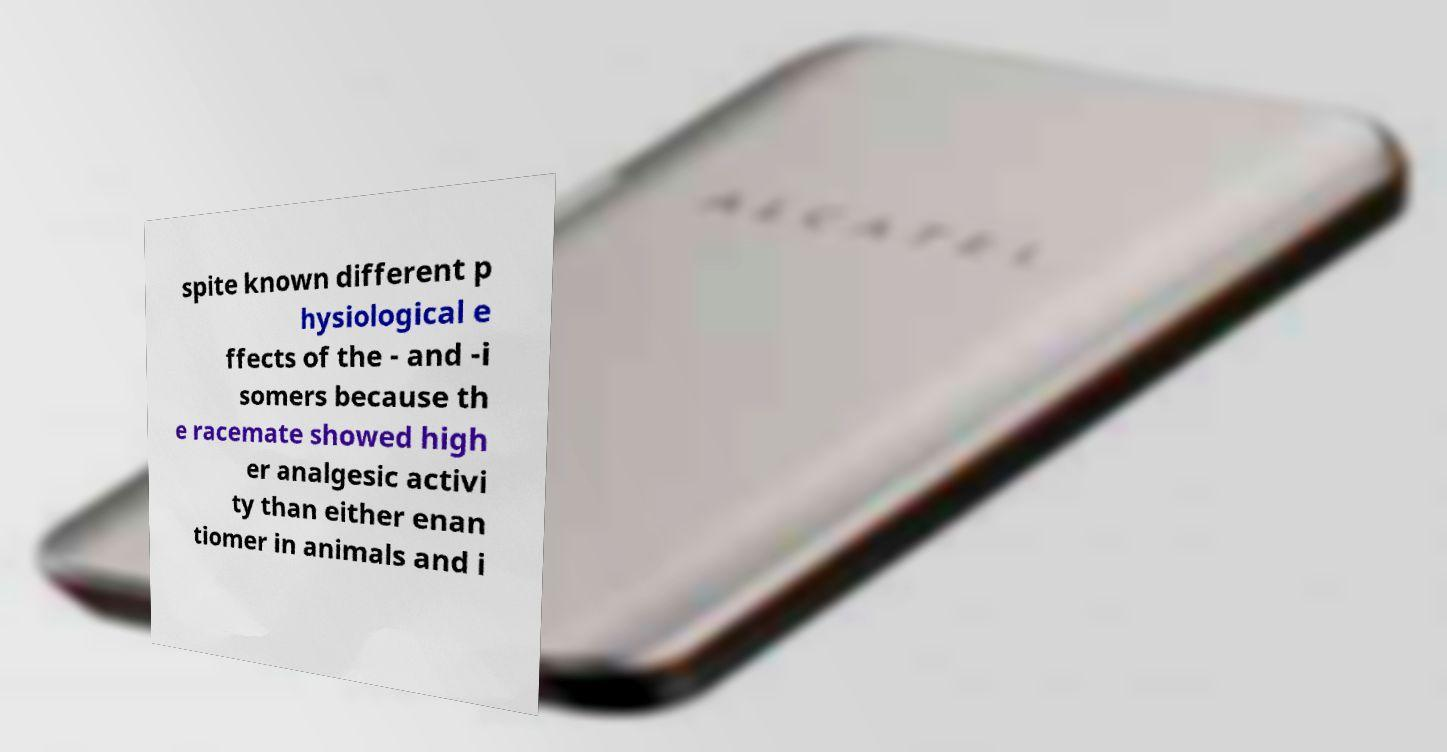For documentation purposes, I need the text within this image transcribed. Could you provide that? spite known different p hysiological e ffects of the - and -i somers because th e racemate showed high er analgesic activi ty than either enan tiomer in animals and i 